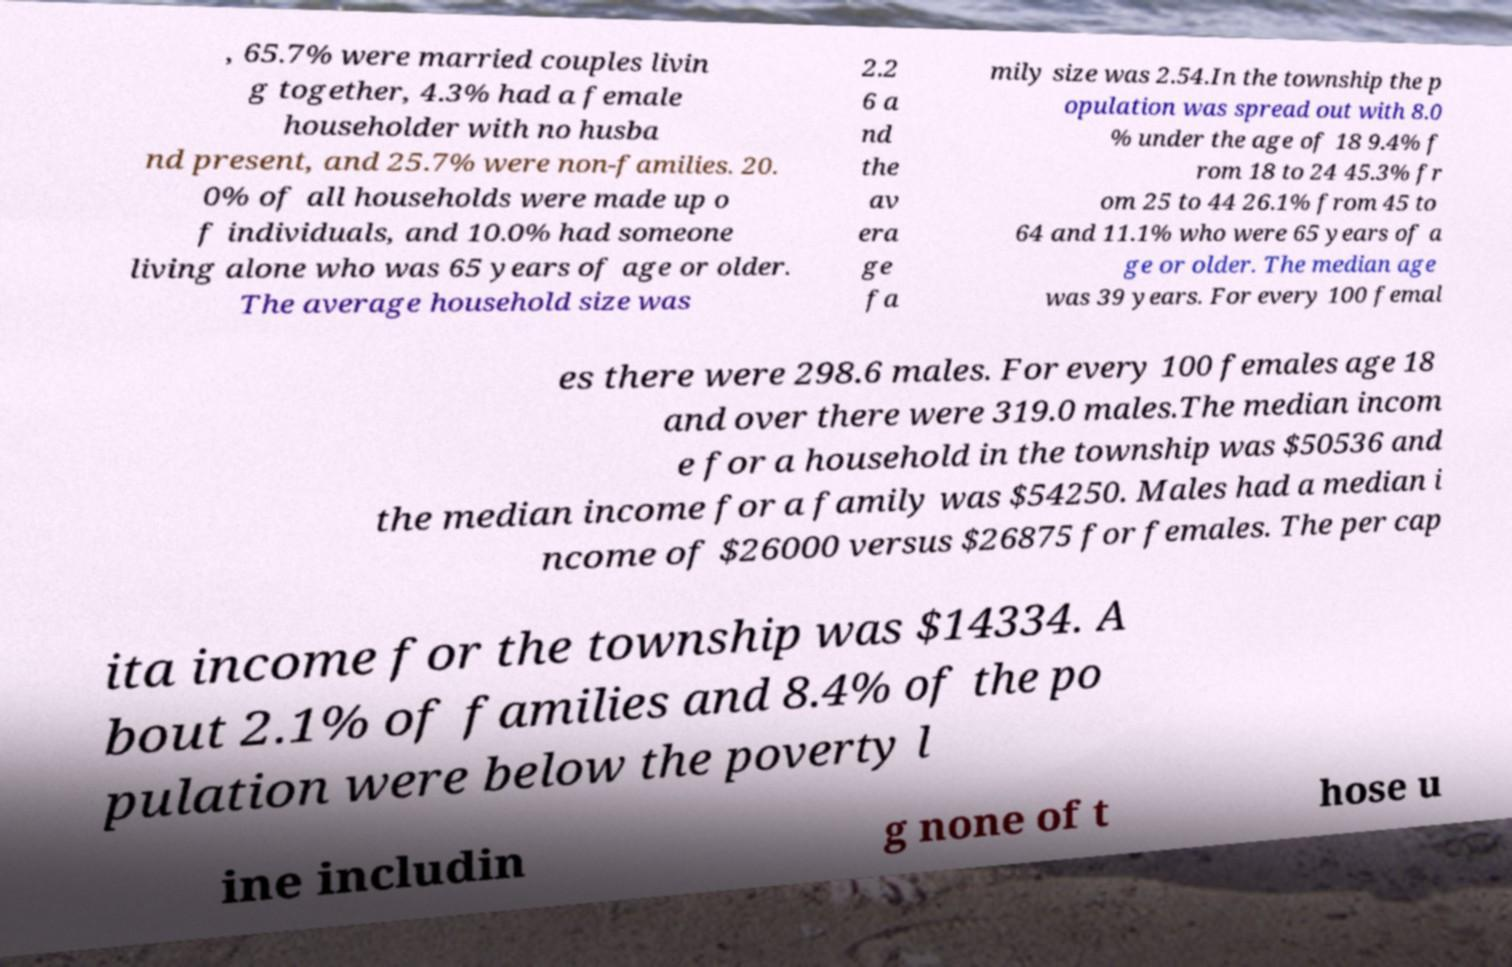Can you accurately transcribe the text from the provided image for me? , 65.7% were married couples livin g together, 4.3% had a female householder with no husba nd present, and 25.7% were non-families. 20. 0% of all households were made up o f individuals, and 10.0% had someone living alone who was 65 years of age or older. The average household size was 2.2 6 a nd the av era ge fa mily size was 2.54.In the township the p opulation was spread out with 8.0 % under the age of 18 9.4% f rom 18 to 24 45.3% fr om 25 to 44 26.1% from 45 to 64 and 11.1% who were 65 years of a ge or older. The median age was 39 years. For every 100 femal es there were 298.6 males. For every 100 females age 18 and over there were 319.0 males.The median incom e for a household in the township was $50536 and the median income for a family was $54250. Males had a median i ncome of $26000 versus $26875 for females. The per cap ita income for the township was $14334. A bout 2.1% of families and 8.4% of the po pulation were below the poverty l ine includin g none of t hose u 